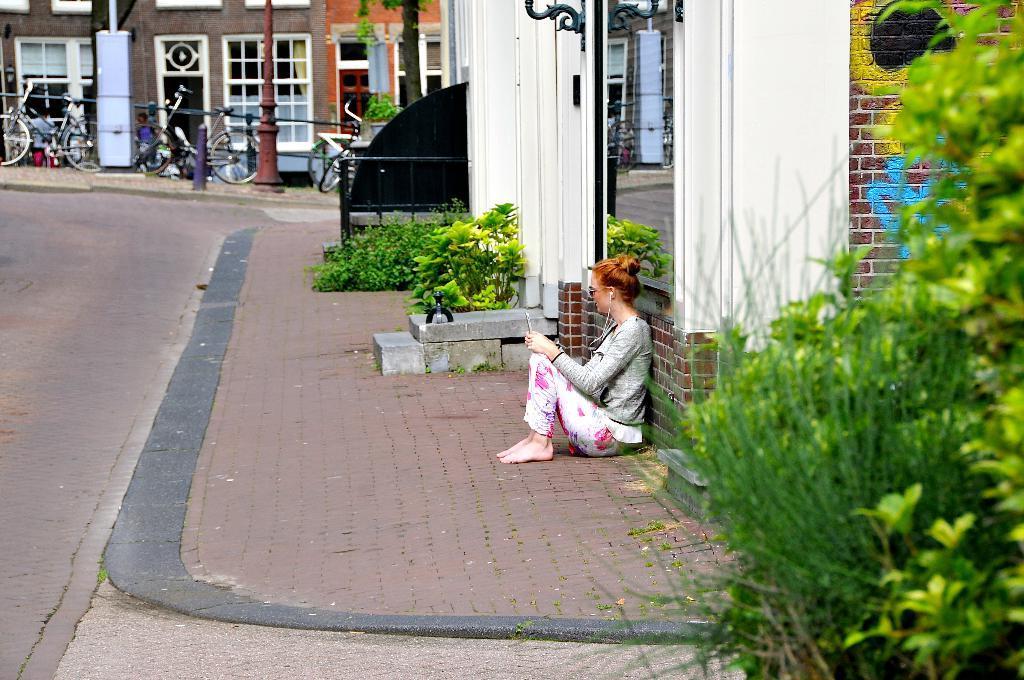Please provide a concise description of this image. In the center of the image we can see a person is sitting and she is holding some object. On the right side of the image, we can see plants. In the background, we can see buildings, plants, poles, cycles and a few other objects. 